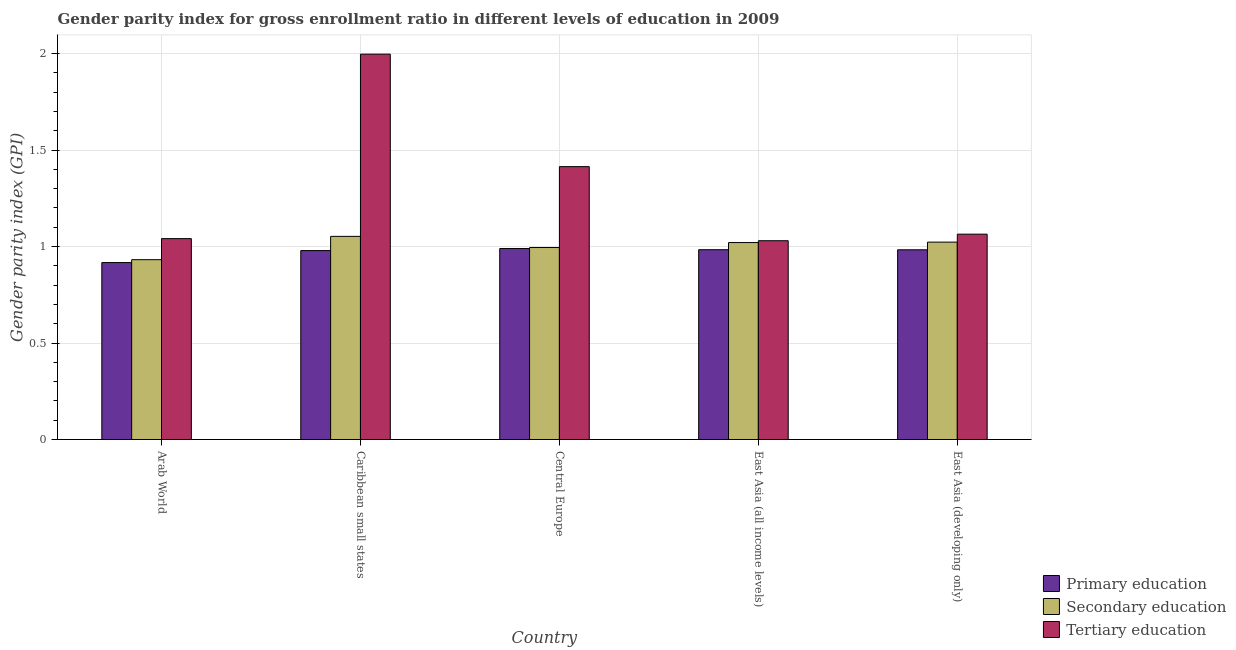How many groups of bars are there?
Ensure brevity in your answer.  5. How many bars are there on the 4th tick from the right?
Ensure brevity in your answer.  3. What is the label of the 4th group of bars from the left?
Offer a very short reply. East Asia (all income levels). What is the gender parity index in tertiary education in Arab World?
Your answer should be very brief. 1.04. Across all countries, what is the maximum gender parity index in tertiary education?
Your answer should be compact. 2. Across all countries, what is the minimum gender parity index in tertiary education?
Your response must be concise. 1.03. In which country was the gender parity index in secondary education maximum?
Your answer should be very brief. Caribbean small states. In which country was the gender parity index in primary education minimum?
Offer a very short reply. Arab World. What is the total gender parity index in tertiary education in the graph?
Provide a succinct answer. 6.55. What is the difference between the gender parity index in tertiary education in Arab World and that in East Asia (developing only)?
Ensure brevity in your answer.  -0.02. What is the difference between the gender parity index in tertiary education in Arab World and the gender parity index in primary education in Central Europe?
Offer a terse response. 0.05. What is the average gender parity index in primary education per country?
Offer a very short reply. 0.97. What is the difference between the gender parity index in primary education and gender parity index in secondary education in East Asia (all income levels)?
Keep it short and to the point. -0.04. In how many countries, is the gender parity index in tertiary education greater than 0.2 ?
Provide a succinct answer. 5. What is the ratio of the gender parity index in secondary education in Arab World to that in Caribbean small states?
Provide a short and direct response. 0.89. Is the gender parity index in primary education in Arab World less than that in East Asia (developing only)?
Give a very brief answer. Yes. Is the difference between the gender parity index in tertiary education in Arab World and Central Europe greater than the difference between the gender parity index in secondary education in Arab World and Central Europe?
Your answer should be very brief. No. What is the difference between the highest and the second highest gender parity index in secondary education?
Provide a short and direct response. 0.03. What is the difference between the highest and the lowest gender parity index in primary education?
Your answer should be compact. 0.07. In how many countries, is the gender parity index in secondary education greater than the average gender parity index in secondary education taken over all countries?
Ensure brevity in your answer.  3. What does the 3rd bar from the left in East Asia (developing only) represents?
Keep it short and to the point. Tertiary education. What does the 2nd bar from the right in Caribbean small states represents?
Offer a terse response. Secondary education. Is it the case that in every country, the sum of the gender parity index in primary education and gender parity index in secondary education is greater than the gender parity index in tertiary education?
Offer a very short reply. Yes. How many bars are there?
Your answer should be very brief. 15. Are all the bars in the graph horizontal?
Offer a very short reply. No. How many countries are there in the graph?
Your response must be concise. 5. Does the graph contain any zero values?
Your response must be concise. No. What is the title of the graph?
Give a very brief answer. Gender parity index for gross enrollment ratio in different levels of education in 2009. What is the label or title of the X-axis?
Your response must be concise. Country. What is the label or title of the Y-axis?
Your response must be concise. Gender parity index (GPI). What is the Gender parity index (GPI) of Primary education in Arab World?
Provide a succinct answer. 0.92. What is the Gender parity index (GPI) in Secondary education in Arab World?
Offer a terse response. 0.93. What is the Gender parity index (GPI) in Tertiary education in Arab World?
Keep it short and to the point. 1.04. What is the Gender parity index (GPI) of Primary education in Caribbean small states?
Offer a terse response. 0.98. What is the Gender parity index (GPI) in Secondary education in Caribbean small states?
Offer a very short reply. 1.05. What is the Gender parity index (GPI) of Tertiary education in Caribbean small states?
Offer a terse response. 2. What is the Gender parity index (GPI) in Primary education in Central Europe?
Ensure brevity in your answer.  0.99. What is the Gender parity index (GPI) of Secondary education in Central Europe?
Provide a succinct answer. 1. What is the Gender parity index (GPI) of Tertiary education in Central Europe?
Provide a short and direct response. 1.41. What is the Gender parity index (GPI) of Primary education in East Asia (all income levels)?
Keep it short and to the point. 0.98. What is the Gender parity index (GPI) in Secondary education in East Asia (all income levels)?
Give a very brief answer. 1.02. What is the Gender parity index (GPI) of Tertiary education in East Asia (all income levels)?
Offer a terse response. 1.03. What is the Gender parity index (GPI) of Primary education in East Asia (developing only)?
Provide a short and direct response. 0.98. What is the Gender parity index (GPI) of Secondary education in East Asia (developing only)?
Your response must be concise. 1.02. What is the Gender parity index (GPI) in Tertiary education in East Asia (developing only)?
Provide a short and direct response. 1.06. Across all countries, what is the maximum Gender parity index (GPI) in Primary education?
Your answer should be compact. 0.99. Across all countries, what is the maximum Gender parity index (GPI) of Secondary education?
Provide a succinct answer. 1.05. Across all countries, what is the maximum Gender parity index (GPI) in Tertiary education?
Provide a succinct answer. 2. Across all countries, what is the minimum Gender parity index (GPI) in Primary education?
Give a very brief answer. 0.92. Across all countries, what is the minimum Gender parity index (GPI) in Secondary education?
Give a very brief answer. 0.93. Across all countries, what is the minimum Gender parity index (GPI) in Tertiary education?
Your answer should be compact. 1.03. What is the total Gender parity index (GPI) in Primary education in the graph?
Provide a short and direct response. 4.85. What is the total Gender parity index (GPI) in Secondary education in the graph?
Make the answer very short. 5.02. What is the total Gender parity index (GPI) of Tertiary education in the graph?
Make the answer very short. 6.55. What is the difference between the Gender parity index (GPI) in Primary education in Arab World and that in Caribbean small states?
Your answer should be compact. -0.06. What is the difference between the Gender parity index (GPI) of Secondary education in Arab World and that in Caribbean small states?
Make the answer very short. -0.12. What is the difference between the Gender parity index (GPI) in Tertiary education in Arab World and that in Caribbean small states?
Give a very brief answer. -0.96. What is the difference between the Gender parity index (GPI) in Primary education in Arab World and that in Central Europe?
Keep it short and to the point. -0.07. What is the difference between the Gender parity index (GPI) of Secondary education in Arab World and that in Central Europe?
Offer a terse response. -0.06. What is the difference between the Gender parity index (GPI) of Tertiary education in Arab World and that in Central Europe?
Your answer should be very brief. -0.37. What is the difference between the Gender parity index (GPI) in Primary education in Arab World and that in East Asia (all income levels)?
Provide a succinct answer. -0.07. What is the difference between the Gender parity index (GPI) in Secondary education in Arab World and that in East Asia (all income levels)?
Provide a succinct answer. -0.09. What is the difference between the Gender parity index (GPI) of Tertiary education in Arab World and that in East Asia (all income levels)?
Give a very brief answer. 0.01. What is the difference between the Gender parity index (GPI) of Primary education in Arab World and that in East Asia (developing only)?
Offer a very short reply. -0.07. What is the difference between the Gender parity index (GPI) in Secondary education in Arab World and that in East Asia (developing only)?
Offer a terse response. -0.09. What is the difference between the Gender parity index (GPI) in Tertiary education in Arab World and that in East Asia (developing only)?
Your response must be concise. -0.02. What is the difference between the Gender parity index (GPI) of Primary education in Caribbean small states and that in Central Europe?
Your answer should be very brief. -0.01. What is the difference between the Gender parity index (GPI) of Secondary education in Caribbean small states and that in Central Europe?
Your answer should be very brief. 0.06. What is the difference between the Gender parity index (GPI) in Tertiary education in Caribbean small states and that in Central Europe?
Make the answer very short. 0.58. What is the difference between the Gender parity index (GPI) in Primary education in Caribbean small states and that in East Asia (all income levels)?
Keep it short and to the point. -0. What is the difference between the Gender parity index (GPI) in Secondary education in Caribbean small states and that in East Asia (all income levels)?
Offer a very short reply. 0.03. What is the difference between the Gender parity index (GPI) of Tertiary education in Caribbean small states and that in East Asia (all income levels)?
Your response must be concise. 0.97. What is the difference between the Gender parity index (GPI) in Primary education in Caribbean small states and that in East Asia (developing only)?
Your answer should be very brief. -0. What is the difference between the Gender parity index (GPI) in Secondary education in Caribbean small states and that in East Asia (developing only)?
Your answer should be compact. 0.03. What is the difference between the Gender parity index (GPI) of Tertiary education in Caribbean small states and that in East Asia (developing only)?
Your answer should be very brief. 0.93. What is the difference between the Gender parity index (GPI) in Primary education in Central Europe and that in East Asia (all income levels)?
Keep it short and to the point. 0.01. What is the difference between the Gender parity index (GPI) in Secondary education in Central Europe and that in East Asia (all income levels)?
Provide a short and direct response. -0.03. What is the difference between the Gender parity index (GPI) in Tertiary education in Central Europe and that in East Asia (all income levels)?
Give a very brief answer. 0.38. What is the difference between the Gender parity index (GPI) in Primary education in Central Europe and that in East Asia (developing only)?
Your answer should be very brief. 0.01. What is the difference between the Gender parity index (GPI) in Secondary education in Central Europe and that in East Asia (developing only)?
Your answer should be very brief. -0.03. What is the difference between the Gender parity index (GPI) of Tertiary education in Central Europe and that in East Asia (developing only)?
Offer a very short reply. 0.35. What is the difference between the Gender parity index (GPI) in Primary education in East Asia (all income levels) and that in East Asia (developing only)?
Your answer should be compact. 0. What is the difference between the Gender parity index (GPI) in Secondary education in East Asia (all income levels) and that in East Asia (developing only)?
Offer a very short reply. -0. What is the difference between the Gender parity index (GPI) of Tertiary education in East Asia (all income levels) and that in East Asia (developing only)?
Keep it short and to the point. -0.03. What is the difference between the Gender parity index (GPI) in Primary education in Arab World and the Gender parity index (GPI) in Secondary education in Caribbean small states?
Your answer should be compact. -0.14. What is the difference between the Gender parity index (GPI) of Primary education in Arab World and the Gender parity index (GPI) of Tertiary education in Caribbean small states?
Give a very brief answer. -1.08. What is the difference between the Gender parity index (GPI) in Secondary education in Arab World and the Gender parity index (GPI) in Tertiary education in Caribbean small states?
Keep it short and to the point. -1.07. What is the difference between the Gender parity index (GPI) in Primary education in Arab World and the Gender parity index (GPI) in Secondary education in Central Europe?
Your response must be concise. -0.08. What is the difference between the Gender parity index (GPI) of Primary education in Arab World and the Gender parity index (GPI) of Tertiary education in Central Europe?
Give a very brief answer. -0.5. What is the difference between the Gender parity index (GPI) in Secondary education in Arab World and the Gender parity index (GPI) in Tertiary education in Central Europe?
Your answer should be compact. -0.48. What is the difference between the Gender parity index (GPI) in Primary education in Arab World and the Gender parity index (GPI) in Secondary education in East Asia (all income levels)?
Make the answer very short. -0.1. What is the difference between the Gender parity index (GPI) of Primary education in Arab World and the Gender parity index (GPI) of Tertiary education in East Asia (all income levels)?
Keep it short and to the point. -0.11. What is the difference between the Gender parity index (GPI) in Secondary education in Arab World and the Gender parity index (GPI) in Tertiary education in East Asia (all income levels)?
Keep it short and to the point. -0.1. What is the difference between the Gender parity index (GPI) in Primary education in Arab World and the Gender parity index (GPI) in Secondary education in East Asia (developing only)?
Give a very brief answer. -0.11. What is the difference between the Gender parity index (GPI) of Primary education in Arab World and the Gender parity index (GPI) of Tertiary education in East Asia (developing only)?
Offer a very short reply. -0.15. What is the difference between the Gender parity index (GPI) of Secondary education in Arab World and the Gender parity index (GPI) of Tertiary education in East Asia (developing only)?
Your response must be concise. -0.13. What is the difference between the Gender parity index (GPI) in Primary education in Caribbean small states and the Gender parity index (GPI) in Secondary education in Central Europe?
Make the answer very short. -0.02. What is the difference between the Gender parity index (GPI) in Primary education in Caribbean small states and the Gender parity index (GPI) in Tertiary education in Central Europe?
Provide a short and direct response. -0.44. What is the difference between the Gender parity index (GPI) of Secondary education in Caribbean small states and the Gender parity index (GPI) of Tertiary education in Central Europe?
Keep it short and to the point. -0.36. What is the difference between the Gender parity index (GPI) in Primary education in Caribbean small states and the Gender parity index (GPI) in Secondary education in East Asia (all income levels)?
Offer a terse response. -0.04. What is the difference between the Gender parity index (GPI) of Primary education in Caribbean small states and the Gender parity index (GPI) of Tertiary education in East Asia (all income levels)?
Your answer should be compact. -0.05. What is the difference between the Gender parity index (GPI) in Secondary education in Caribbean small states and the Gender parity index (GPI) in Tertiary education in East Asia (all income levels)?
Your response must be concise. 0.02. What is the difference between the Gender parity index (GPI) of Primary education in Caribbean small states and the Gender parity index (GPI) of Secondary education in East Asia (developing only)?
Ensure brevity in your answer.  -0.04. What is the difference between the Gender parity index (GPI) in Primary education in Caribbean small states and the Gender parity index (GPI) in Tertiary education in East Asia (developing only)?
Offer a very short reply. -0.09. What is the difference between the Gender parity index (GPI) in Secondary education in Caribbean small states and the Gender parity index (GPI) in Tertiary education in East Asia (developing only)?
Ensure brevity in your answer.  -0.01. What is the difference between the Gender parity index (GPI) of Primary education in Central Europe and the Gender parity index (GPI) of Secondary education in East Asia (all income levels)?
Your answer should be compact. -0.03. What is the difference between the Gender parity index (GPI) in Primary education in Central Europe and the Gender parity index (GPI) in Tertiary education in East Asia (all income levels)?
Provide a short and direct response. -0.04. What is the difference between the Gender parity index (GPI) in Secondary education in Central Europe and the Gender parity index (GPI) in Tertiary education in East Asia (all income levels)?
Your response must be concise. -0.04. What is the difference between the Gender parity index (GPI) in Primary education in Central Europe and the Gender parity index (GPI) in Secondary education in East Asia (developing only)?
Offer a terse response. -0.03. What is the difference between the Gender parity index (GPI) of Primary education in Central Europe and the Gender parity index (GPI) of Tertiary education in East Asia (developing only)?
Offer a very short reply. -0.07. What is the difference between the Gender parity index (GPI) in Secondary education in Central Europe and the Gender parity index (GPI) in Tertiary education in East Asia (developing only)?
Offer a terse response. -0.07. What is the difference between the Gender parity index (GPI) of Primary education in East Asia (all income levels) and the Gender parity index (GPI) of Secondary education in East Asia (developing only)?
Your response must be concise. -0.04. What is the difference between the Gender parity index (GPI) in Primary education in East Asia (all income levels) and the Gender parity index (GPI) in Tertiary education in East Asia (developing only)?
Your answer should be very brief. -0.08. What is the difference between the Gender parity index (GPI) in Secondary education in East Asia (all income levels) and the Gender parity index (GPI) in Tertiary education in East Asia (developing only)?
Offer a very short reply. -0.04. What is the average Gender parity index (GPI) in Primary education per country?
Make the answer very short. 0.97. What is the average Gender parity index (GPI) in Secondary education per country?
Ensure brevity in your answer.  1. What is the average Gender parity index (GPI) in Tertiary education per country?
Provide a succinct answer. 1.31. What is the difference between the Gender parity index (GPI) in Primary education and Gender parity index (GPI) in Secondary education in Arab World?
Provide a short and direct response. -0.01. What is the difference between the Gender parity index (GPI) of Primary education and Gender parity index (GPI) of Tertiary education in Arab World?
Offer a very short reply. -0.12. What is the difference between the Gender parity index (GPI) of Secondary education and Gender parity index (GPI) of Tertiary education in Arab World?
Your answer should be very brief. -0.11. What is the difference between the Gender parity index (GPI) in Primary education and Gender parity index (GPI) in Secondary education in Caribbean small states?
Your response must be concise. -0.07. What is the difference between the Gender parity index (GPI) in Primary education and Gender parity index (GPI) in Tertiary education in Caribbean small states?
Offer a terse response. -1.02. What is the difference between the Gender parity index (GPI) in Secondary education and Gender parity index (GPI) in Tertiary education in Caribbean small states?
Your response must be concise. -0.94. What is the difference between the Gender parity index (GPI) in Primary education and Gender parity index (GPI) in Secondary education in Central Europe?
Your answer should be very brief. -0.01. What is the difference between the Gender parity index (GPI) in Primary education and Gender parity index (GPI) in Tertiary education in Central Europe?
Your answer should be compact. -0.42. What is the difference between the Gender parity index (GPI) in Secondary education and Gender parity index (GPI) in Tertiary education in Central Europe?
Your answer should be very brief. -0.42. What is the difference between the Gender parity index (GPI) of Primary education and Gender parity index (GPI) of Secondary education in East Asia (all income levels)?
Give a very brief answer. -0.04. What is the difference between the Gender parity index (GPI) of Primary education and Gender parity index (GPI) of Tertiary education in East Asia (all income levels)?
Your answer should be compact. -0.05. What is the difference between the Gender parity index (GPI) of Secondary education and Gender parity index (GPI) of Tertiary education in East Asia (all income levels)?
Ensure brevity in your answer.  -0.01. What is the difference between the Gender parity index (GPI) in Primary education and Gender parity index (GPI) in Secondary education in East Asia (developing only)?
Keep it short and to the point. -0.04. What is the difference between the Gender parity index (GPI) in Primary education and Gender parity index (GPI) in Tertiary education in East Asia (developing only)?
Keep it short and to the point. -0.08. What is the difference between the Gender parity index (GPI) in Secondary education and Gender parity index (GPI) in Tertiary education in East Asia (developing only)?
Provide a short and direct response. -0.04. What is the ratio of the Gender parity index (GPI) in Primary education in Arab World to that in Caribbean small states?
Keep it short and to the point. 0.94. What is the ratio of the Gender parity index (GPI) in Secondary education in Arab World to that in Caribbean small states?
Your answer should be very brief. 0.89. What is the ratio of the Gender parity index (GPI) in Tertiary education in Arab World to that in Caribbean small states?
Ensure brevity in your answer.  0.52. What is the ratio of the Gender parity index (GPI) in Primary education in Arab World to that in Central Europe?
Ensure brevity in your answer.  0.93. What is the ratio of the Gender parity index (GPI) of Secondary education in Arab World to that in Central Europe?
Provide a short and direct response. 0.94. What is the ratio of the Gender parity index (GPI) in Tertiary education in Arab World to that in Central Europe?
Your answer should be very brief. 0.74. What is the ratio of the Gender parity index (GPI) in Primary education in Arab World to that in East Asia (all income levels)?
Your answer should be compact. 0.93. What is the ratio of the Gender parity index (GPI) in Secondary education in Arab World to that in East Asia (all income levels)?
Ensure brevity in your answer.  0.91. What is the ratio of the Gender parity index (GPI) of Tertiary education in Arab World to that in East Asia (all income levels)?
Your answer should be very brief. 1.01. What is the ratio of the Gender parity index (GPI) of Primary education in Arab World to that in East Asia (developing only)?
Provide a succinct answer. 0.93. What is the ratio of the Gender parity index (GPI) in Secondary education in Arab World to that in East Asia (developing only)?
Provide a short and direct response. 0.91. What is the ratio of the Gender parity index (GPI) in Tertiary education in Arab World to that in East Asia (developing only)?
Ensure brevity in your answer.  0.98. What is the ratio of the Gender parity index (GPI) of Primary education in Caribbean small states to that in Central Europe?
Your answer should be very brief. 0.99. What is the ratio of the Gender parity index (GPI) of Secondary education in Caribbean small states to that in Central Europe?
Offer a very short reply. 1.06. What is the ratio of the Gender parity index (GPI) in Tertiary education in Caribbean small states to that in Central Europe?
Keep it short and to the point. 1.41. What is the ratio of the Gender parity index (GPI) of Primary education in Caribbean small states to that in East Asia (all income levels)?
Provide a short and direct response. 1. What is the ratio of the Gender parity index (GPI) of Secondary education in Caribbean small states to that in East Asia (all income levels)?
Give a very brief answer. 1.03. What is the ratio of the Gender parity index (GPI) of Tertiary education in Caribbean small states to that in East Asia (all income levels)?
Your answer should be very brief. 1.94. What is the ratio of the Gender parity index (GPI) of Primary education in Caribbean small states to that in East Asia (developing only)?
Your response must be concise. 1. What is the ratio of the Gender parity index (GPI) in Secondary education in Caribbean small states to that in East Asia (developing only)?
Your answer should be compact. 1.03. What is the ratio of the Gender parity index (GPI) of Tertiary education in Caribbean small states to that in East Asia (developing only)?
Provide a short and direct response. 1.88. What is the ratio of the Gender parity index (GPI) in Primary education in Central Europe to that in East Asia (all income levels)?
Make the answer very short. 1.01. What is the ratio of the Gender parity index (GPI) of Secondary education in Central Europe to that in East Asia (all income levels)?
Offer a very short reply. 0.97. What is the ratio of the Gender parity index (GPI) of Tertiary education in Central Europe to that in East Asia (all income levels)?
Offer a very short reply. 1.37. What is the ratio of the Gender parity index (GPI) of Primary education in Central Europe to that in East Asia (developing only)?
Your answer should be very brief. 1.01. What is the ratio of the Gender parity index (GPI) in Secondary education in Central Europe to that in East Asia (developing only)?
Provide a short and direct response. 0.97. What is the ratio of the Gender parity index (GPI) of Tertiary education in Central Europe to that in East Asia (developing only)?
Offer a terse response. 1.33. What is the difference between the highest and the second highest Gender parity index (GPI) of Primary education?
Ensure brevity in your answer.  0.01. What is the difference between the highest and the second highest Gender parity index (GPI) of Secondary education?
Ensure brevity in your answer.  0.03. What is the difference between the highest and the second highest Gender parity index (GPI) of Tertiary education?
Provide a short and direct response. 0.58. What is the difference between the highest and the lowest Gender parity index (GPI) of Primary education?
Provide a short and direct response. 0.07. What is the difference between the highest and the lowest Gender parity index (GPI) of Secondary education?
Your answer should be very brief. 0.12. What is the difference between the highest and the lowest Gender parity index (GPI) of Tertiary education?
Provide a short and direct response. 0.97. 